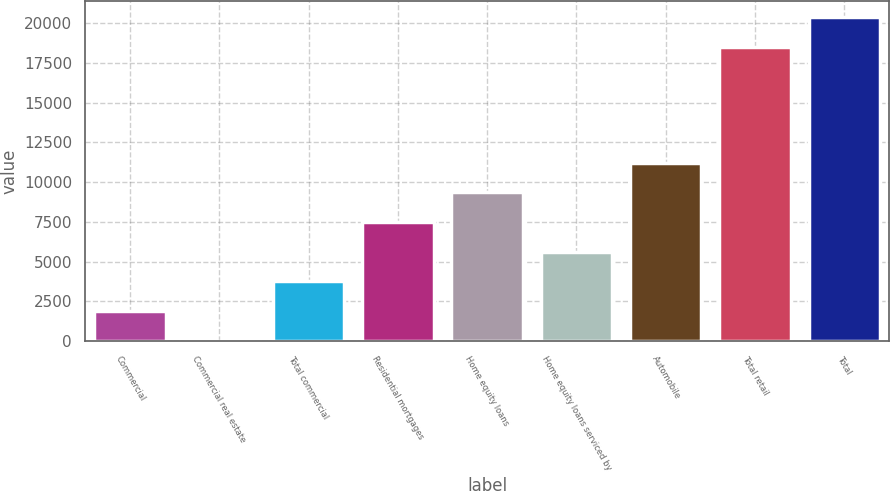Convert chart. <chart><loc_0><loc_0><loc_500><loc_500><bar_chart><fcel>Commercial<fcel>Commercial real estate<fcel>Total commercial<fcel>Residential mortgages<fcel>Home equity loans<fcel>Home equity loans serviced by<fcel>Automobile<fcel>Total retail<fcel>Total<nl><fcel>1883.3<fcel>16<fcel>3750.6<fcel>7485.2<fcel>9352.5<fcel>5617.9<fcel>11219.8<fcel>18493<fcel>20360.3<nl></chart> 